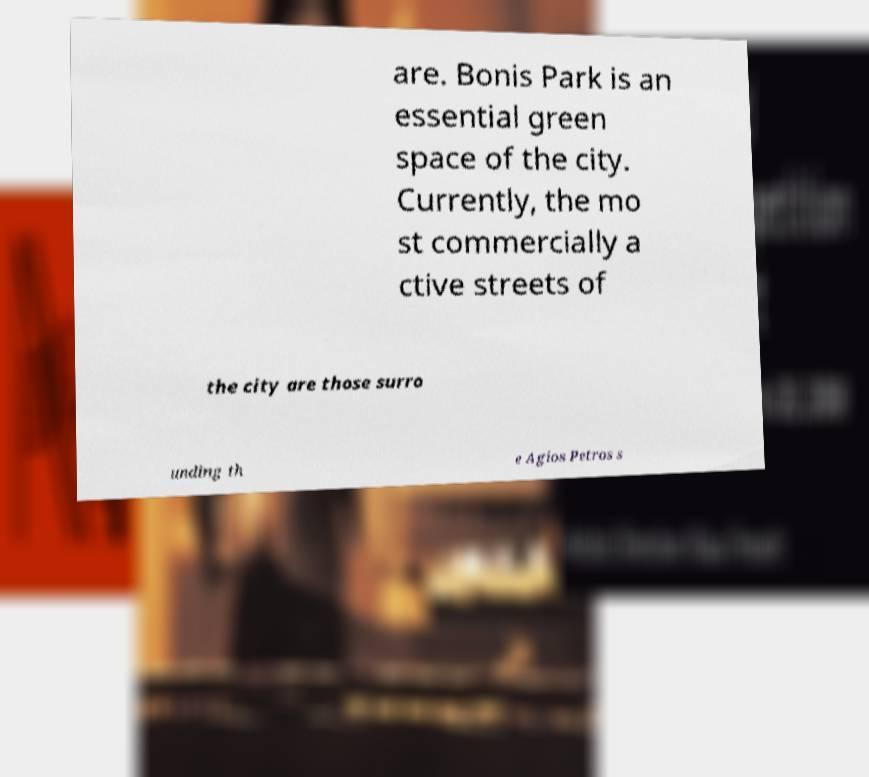Could you assist in decoding the text presented in this image and type it out clearly? are. Bonis Park is an essential green space of the city. Currently, the mo st commercially a ctive streets of the city are those surro unding th e Agios Petros s 